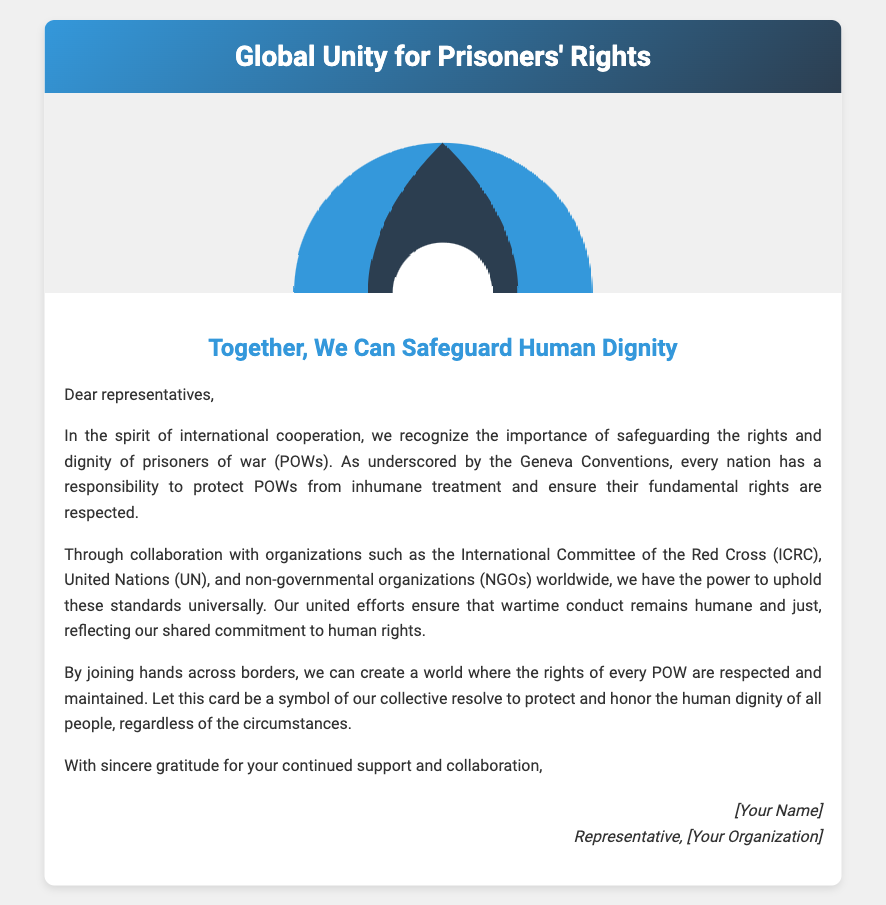What is the title of the card? The title is prominently displayed in the card header and reads "Global Unity for Prisoners' Rights."
Answer: Global Unity for Prisoners' Rights Who is the message addressed to? The opening of the message specifies that it is addressed to "dear representatives."
Answer: representatives What organizations are mentioned in the document? The message refers to the International Committee of the Red Cross, United Nations, and various NGOs.
Answer: ICRC, UN, NGOs What is the main theme of the message? The theme emphasized throughout the message focuses on the importance of cooperation in safeguarding the rights and dignity of POWs.
Answer: safeguarding human dignity What does the card symbolize? The card serves as a symbol of collective resolve to protect and honor human dignity universally.
Answer: collective resolve What colors are used in the card's design? The card features a gradient of blue and dark gray in the header and a white background throughout.
Answer: blue, dark gray, white How should representatives feel about their collaboration? The message expresses gratitude for the continued support and collaboration from the representatives.
Answer: gratitude What is the main purpose of the card? The card aims to emphasize the importance of international cooperation in the treatment of POWs.
Answer: international cooperation 